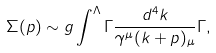<formula> <loc_0><loc_0><loc_500><loc_500>\Sigma ( p ) \sim g \int ^ { \Lambda } \Gamma \frac { d ^ { 4 } k } { \gamma ^ { \mu } ( k + p ) _ { \mu } } \Gamma ,</formula> 